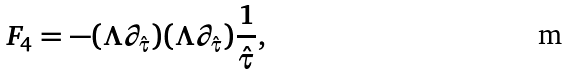<formula> <loc_0><loc_0><loc_500><loc_500>F _ { 4 } = - ( \Lambda \partial _ { \hat { \tau } } ) ( \Lambda \partial _ { \hat { \tau } } ) \frac { 1 } { \hat { \tau } } ,</formula> 